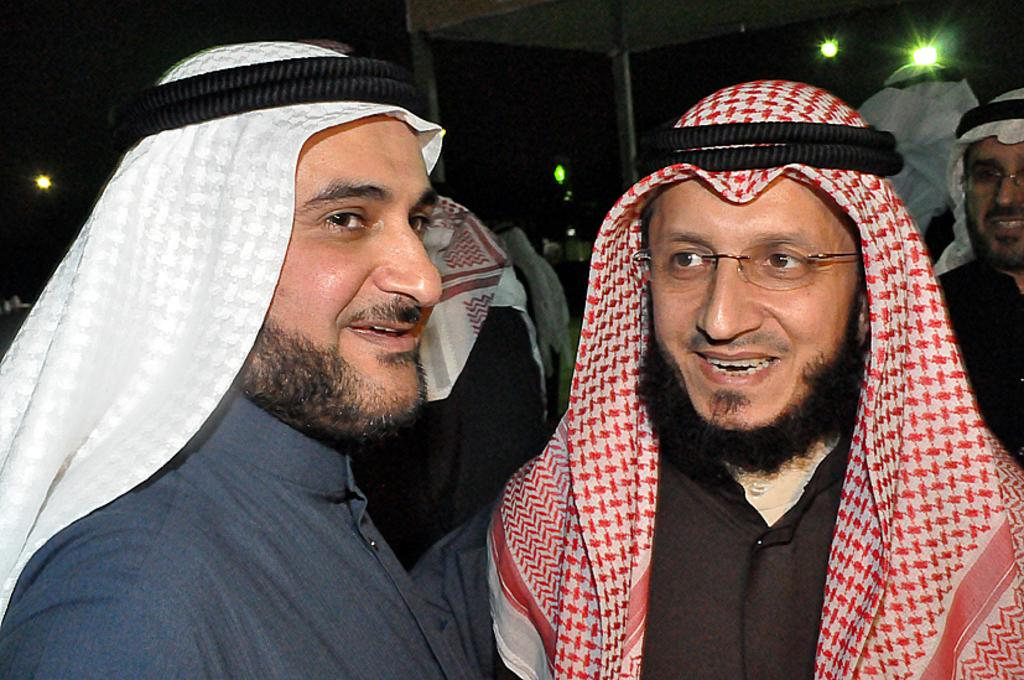How many people are in the image? There are many people in the image. What are the people wearing on their heads? All the people are wearing headgear. Can you describe the man in the front? The man in the front is wearing a black dress. What can be seen in the background of the image? There are lights visible in the background of the image. What type of voice does the son have in the image? There is no son or voice present in the image; it only shows a group of people wearing headgear. Can you describe the chin of the person in the image? The provided facts do not mention any specific person's chin, so it cannot be described. 